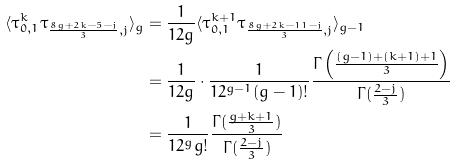<formula> <loc_0><loc_0><loc_500><loc_500>\langle \tau _ { 0 , 1 } ^ { k } \tau _ { \frac { 8 g + 2 k - 5 - j } { 3 } , j } \rangle _ { g } & = \frac { 1 } { 1 2 g } \langle \tau _ { 0 , 1 } ^ { k + 1 } \tau _ { \frac { 8 g + 2 k - 1 1 - j } { 3 } , j } \rangle _ { g - 1 } \\ & = \frac { 1 } { 1 2 g } \cdot \frac { 1 } { 1 2 ^ { g - 1 } ( g - 1 ) ! } \frac { \Gamma \left ( \frac { ( g - 1 ) + ( k + 1 ) + 1 } { 3 } \right ) } { \Gamma ( \frac { 2 - j } { 3 } ) } \\ & = \frac { 1 } { 1 2 ^ { g } g ! } \frac { \Gamma ( \frac { g + k + 1 } { 3 } ) } { \Gamma ( \frac { 2 - j } { 3 } ) }</formula> 